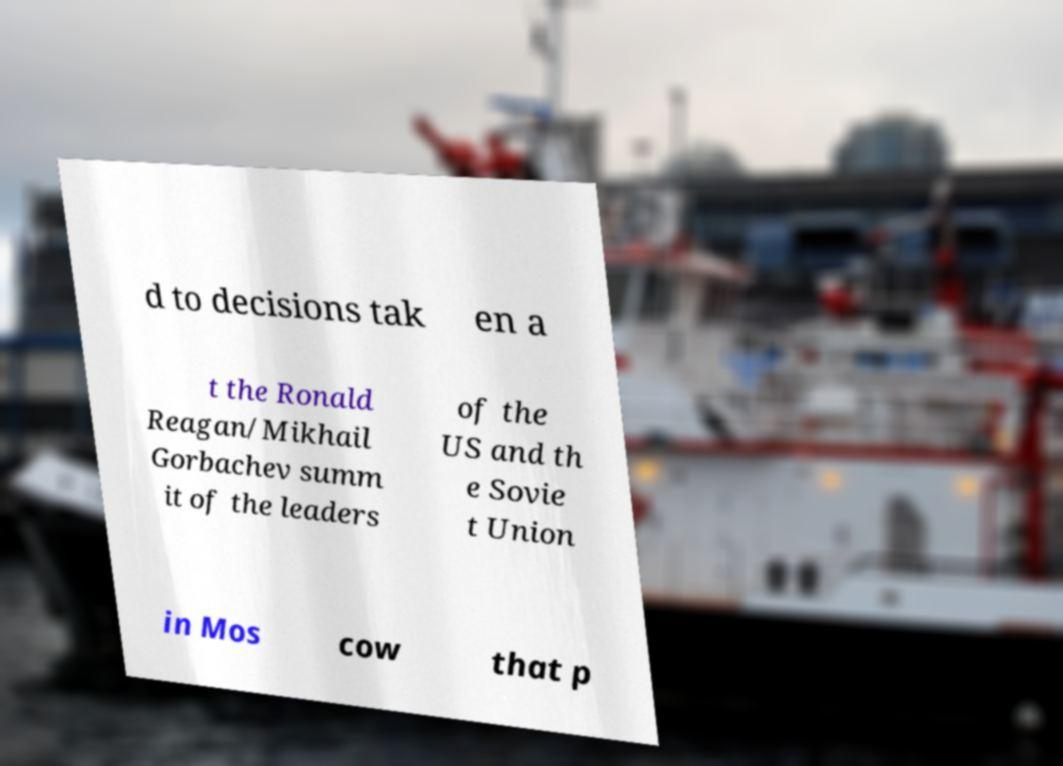There's text embedded in this image that I need extracted. Can you transcribe it verbatim? d to decisions tak en a t the Ronald Reagan/Mikhail Gorbachev summ it of the leaders of the US and th e Sovie t Union in Mos cow that p 